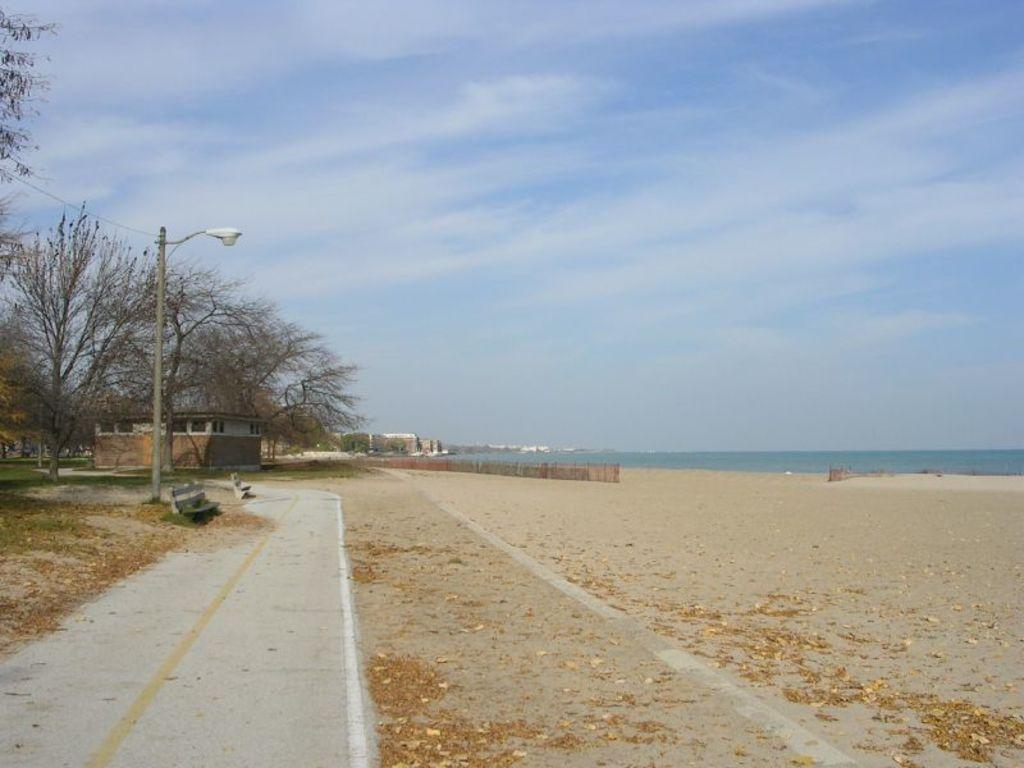How would you summarize this image in a sentence or two? On the left side of the image we can see the houses, trees, pole, light, wire, benches, fence. In the middle of the image we can see the water. At the bottom of the image we can see the soil, dry leaves, pavement and grass. At the top of the image we can see the clouds in the sky. 